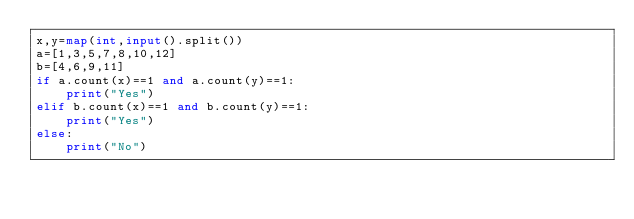<code> <loc_0><loc_0><loc_500><loc_500><_Python_>x,y=map(int,input().split())
a=[1,3,5,7,8,10,12]
b=[4,6,9,11]
if a.count(x)==1 and a.count(y)==1:
    print("Yes")
elif b.count(x)==1 and b.count(y)==1:
    print("Yes")
else:
    print("No")
</code> 